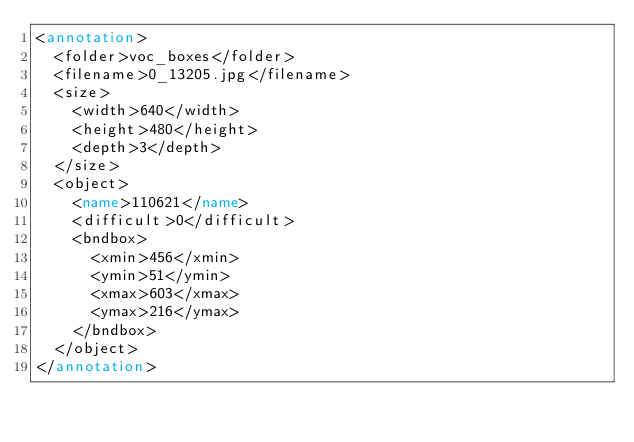Convert code to text. <code><loc_0><loc_0><loc_500><loc_500><_XML_><annotation>
  <folder>voc_boxes</folder>
  <filename>0_13205.jpg</filename>
  <size>
    <width>640</width>
    <height>480</height>
    <depth>3</depth>
  </size>
  <object>
    <name>110621</name>
    <difficult>0</difficult>
    <bndbox>
      <xmin>456</xmin>
      <ymin>51</ymin>
      <xmax>603</xmax>
      <ymax>216</ymax>
    </bndbox>
  </object>
</annotation></code> 